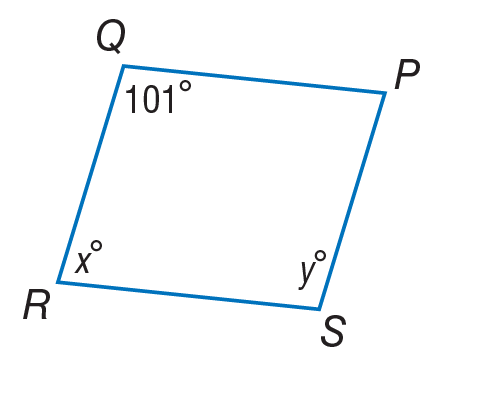Question: Use parallelogram to find x.
Choices:
A. 39
B. 79
C. 101
D. 180
Answer with the letter. Answer: B 